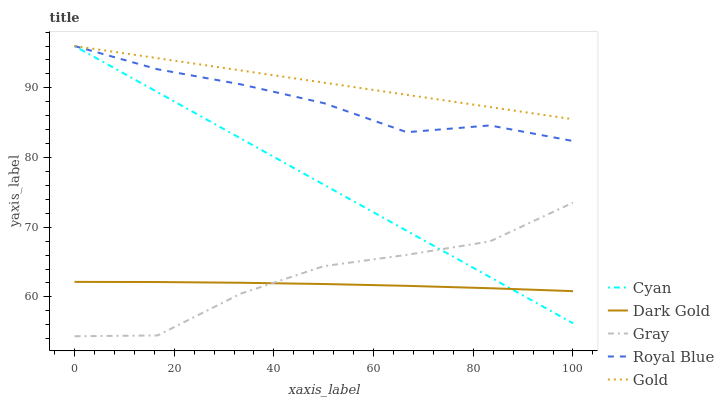Does Gray have the minimum area under the curve?
Answer yes or no. No. Does Gray have the maximum area under the curve?
Answer yes or no. No. Is Gold the smoothest?
Answer yes or no. No. Is Gold the roughest?
Answer yes or no. No. Does Gold have the lowest value?
Answer yes or no. No. Does Gray have the highest value?
Answer yes or no. No. Is Gray less than Gold?
Answer yes or no. Yes. Is Gold greater than Dark Gold?
Answer yes or no. Yes. Does Gray intersect Gold?
Answer yes or no. No. 